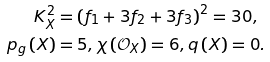Convert formula to latex. <formula><loc_0><loc_0><loc_500><loc_500>K _ { X } ^ { 2 } & = \left ( f _ { 1 } + 3 f _ { 2 } + 3 f _ { 3 } \right ) ^ { 2 } = 3 0 , \\ p _ { g } \left ( X \right ) & = 5 , \chi \left ( \mathcal { O } _ { X } \right ) = 6 , q \left ( X \right ) = 0 .</formula> 